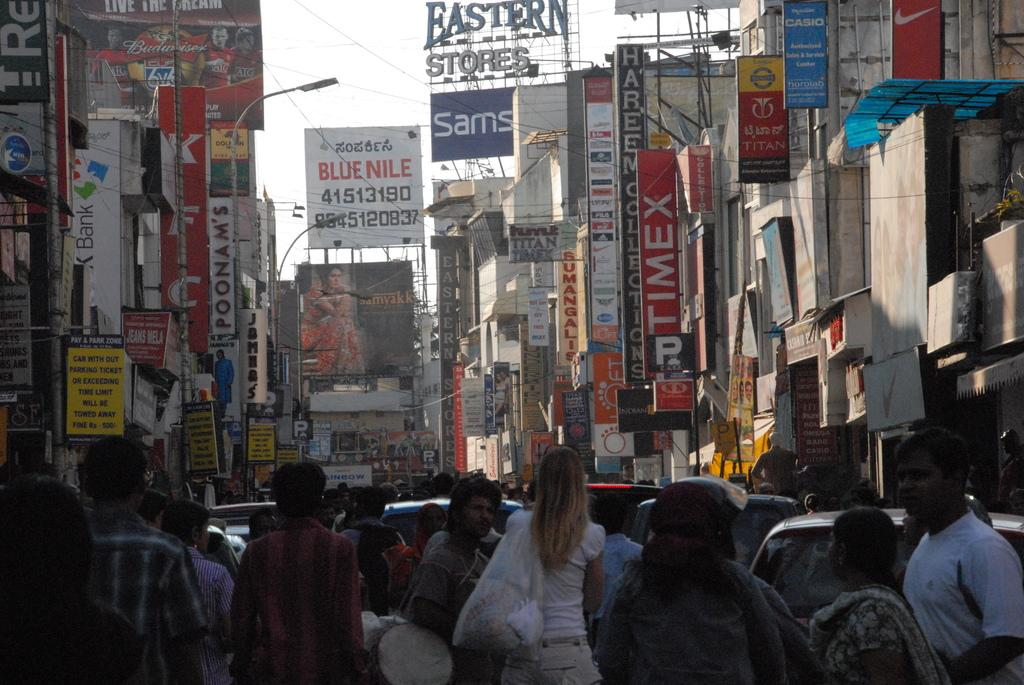How many people are visible in the image? There are people in the image, but the exact number is not specified. What is located behind the people in the image? There are cars behind the people in the image. What type of signage can be seen in the image? There are boards and banners in the image. What type of lighting is present in the image? There are street lights in the image. What type of structures are visible in the image? There are buildings in the image. What part of the natural environment is visible in the image? The sky is visible in the image. What type of soup is being served in the image? There is no soup present in the image. What observation can be made about the weather in the image? The facts provided do not mention any weather conditions, so it is not possible to make an observation about the weather in the image. 